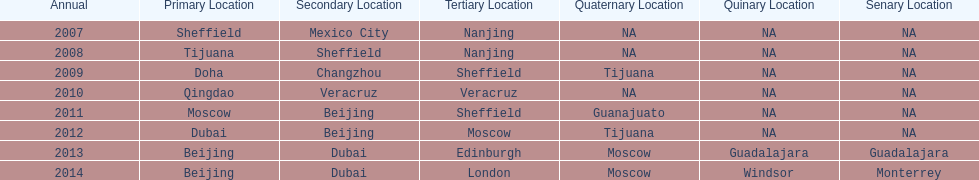Which year had more venues, 2007 or 2012? 2012. 